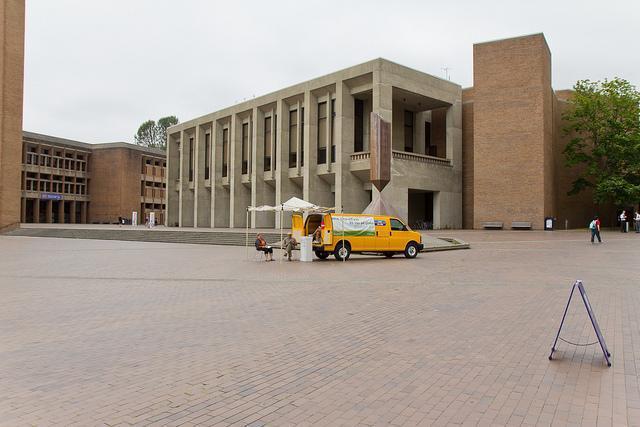How many people are there near the yellow truck?
Give a very brief answer. 2. 